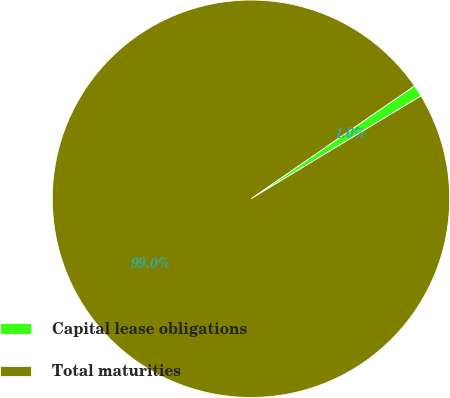Convert chart. <chart><loc_0><loc_0><loc_500><loc_500><pie_chart><fcel>Capital lease obligations<fcel>Total maturities<nl><fcel>0.96%<fcel>99.04%<nl></chart> 